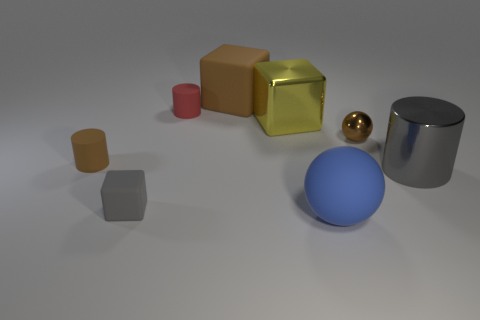Does the small gray object have the same shape as the small brown shiny thing that is behind the small brown matte thing?
Provide a short and direct response. No. Are there any tiny purple rubber balls?
Offer a very short reply. No. How many tiny things are blue rubber things or yellow metal cubes?
Provide a short and direct response. 0. Is the number of large rubber objects that are to the left of the tiny matte block greater than the number of tiny brown matte cylinders behind the big yellow thing?
Your answer should be compact. No. Does the large ball have the same material as the small cylinder in front of the big yellow thing?
Your answer should be very brief. Yes. The rubber sphere has what color?
Make the answer very short. Blue. There is a brown rubber object in front of the large brown matte object; what is its shape?
Provide a succinct answer. Cylinder. How many blue objects are either tiny balls or tiny cubes?
Provide a short and direct response. 0. What is the color of the big sphere that is made of the same material as the big brown object?
Offer a terse response. Blue. There is a metal cylinder; is it the same color as the large matte object that is behind the red object?
Provide a short and direct response. No. 